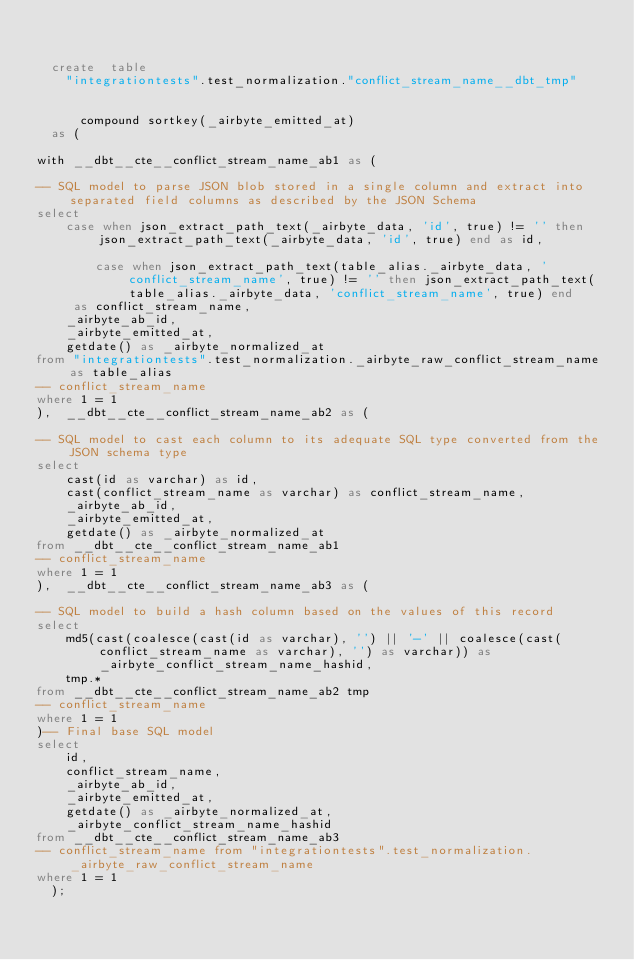<code> <loc_0><loc_0><loc_500><loc_500><_SQL_>

  create  table
    "integrationtests".test_normalization."conflict_stream_name__dbt_tmp"
    
    
      compound sortkey(_airbyte_emitted_at)
  as (
    
with __dbt__cte__conflict_stream_name_ab1 as (

-- SQL model to parse JSON blob stored in a single column and extract into separated field columns as described by the JSON Schema
select
    case when json_extract_path_text(_airbyte_data, 'id', true) != '' then json_extract_path_text(_airbyte_data, 'id', true) end as id,
    
        case when json_extract_path_text(table_alias._airbyte_data, 'conflict_stream_name', true) != '' then json_extract_path_text(table_alias._airbyte_data, 'conflict_stream_name', true) end
     as conflict_stream_name,
    _airbyte_ab_id,
    _airbyte_emitted_at,
    getdate() as _airbyte_normalized_at
from "integrationtests".test_normalization._airbyte_raw_conflict_stream_name as table_alias
-- conflict_stream_name
where 1 = 1
),  __dbt__cte__conflict_stream_name_ab2 as (

-- SQL model to cast each column to its adequate SQL type converted from the JSON schema type
select
    cast(id as varchar) as id,
    cast(conflict_stream_name as varchar) as conflict_stream_name,
    _airbyte_ab_id,
    _airbyte_emitted_at,
    getdate() as _airbyte_normalized_at
from __dbt__cte__conflict_stream_name_ab1
-- conflict_stream_name
where 1 = 1
),  __dbt__cte__conflict_stream_name_ab3 as (

-- SQL model to build a hash column based on the values of this record
select
    md5(cast(coalesce(cast(id as varchar), '') || '-' || coalesce(cast(conflict_stream_name as varchar), '') as varchar)) as _airbyte_conflict_stream_name_hashid,
    tmp.*
from __dbt__cte__conflict_stream_name_ab2 tmp
-- conflict_stream_name
where 1 = 1
)-- Final base SQL model
select
    id,
    conflict_stream_name,
    _airbyte_ab_id,
    _airbyte_emitted_at,
    getdate() as _airbyte_normalized_at,
    _airbyte_conflict_stream_name_hashid
from __dbt__cte__conflict_stream_name_ab3
-- conflict_stream_name from "integrationtests".test_normalization._airbyte_raw_conflict_stream_name
where 1 = 1
  );</code> 